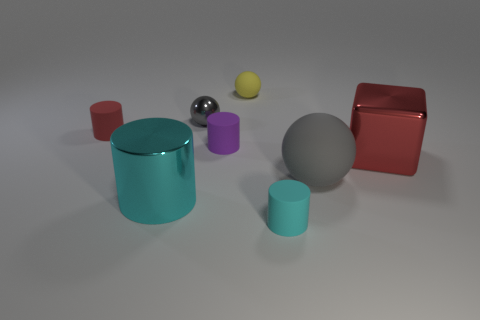Are there any rubber objects behind the small purple rubber cylinder?
Your response must be concise. Yes. How many metal objects are cubes or large cyan things?
Keep it short and to the point. 2. How many tiny red objects are left of the large shiny block?
Give a very brief answer. 1. Is there a shiny thing that has the same size as the gray metal ball?
Give a very brief answer. No. Is there a rubber cylinder that has the same color as the cube?
Provide a short and direct response. Yes. Are there any other things that are the same size as the cyan matte cylinder?
Offer a terse response. Yes. What number of things have the same color as the metal cylinder?
Offer a very short reply. 1. Is the color of the cube the same as the rubber cylinder that is right of the purple rubber thing?
Provide a short and direct response. No. How many objects are big purple cylinders or matte cylinders that are behind the big red metal thing?
Your answer should be very brief. 2. There is a gray object behind the large metal object that is behind the large rubber sphere; how big is it?
Keep it short and to the point. Small. 